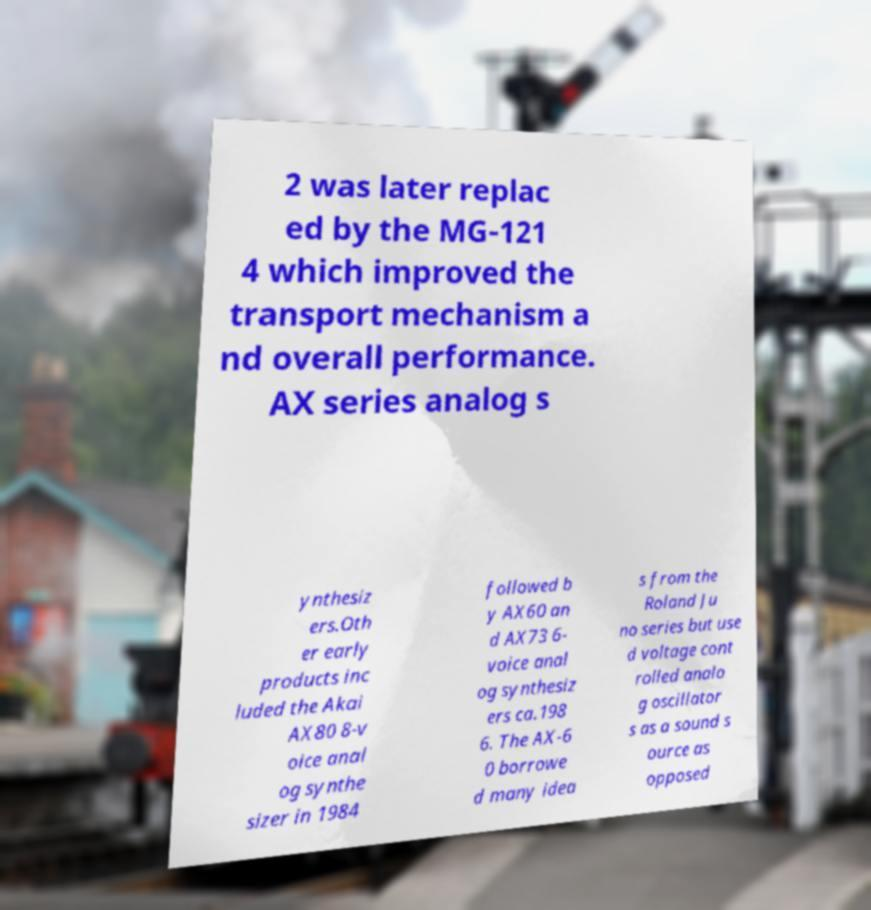I need the written content from this picture converted into text. Can you do that? 2 was later replac ed by the MG-121 4 which improved the transport mechanism a nd overall performance. AX series analog s ynthesiz ers.Oth er early products inc luded the Akai AX80 8-v oice anal og synthe sizer in 1984 followed b y AX60 an d AX73 6- voice anal og synthesiz ers ca.198 6. The AX-6 0 borrowe d many idea s from the Roland Ju no series but use d voltage cont rolled analo g oscillator s as a sound s ource as opposed 